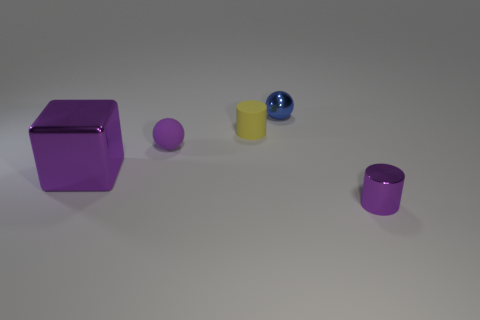What size is the blue metal thing that is the same shape as the purple rubber object?
Keep it short and to the point. Small. How many things are both behind the small yellow object and on the left side of the tiny purple sphere?
Offer a terse response. 0. There is a tiny yellow thing; does it have the same shape as the purple shiny object on the left side of the small purple metallic cylinder?
Make the answer very short. No. Is the number of spheres behind the purple matte thing greater than the number of purple balls?
Your answer should be very brief. No. Are there fewer purple shiny blocks in front of the big cube than big metallic cubes?
Ensure brevity in your answer.  Yes. How many small spheres have the same color as the cube?
Give a very brief answer. 1. What is the object that is left of the yellow matte cylinder and on the right side of the large thing made of?
Your answer should be very brief. Rubber. Do the cylinder that is to the right of the blue shiny sphere and the tiny metal object that is behind the shiny cylinder have the same color?
Ensure brevity in your answer.  No. How many blue things are tiny balls or big cubes?
Offer a terse response. 1. Is the number of small blue spheres that are left of the blue thing less than the number of big blocks on the right side of the large purple metal thing?
Your answer should be compact. No. 